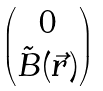Convert formula to latex. <formula><loc_0><loc_0><loc_500><loc_500>\begin{pmatrix} 0 \\ \tilde { B } ( \vec { r } ) \end{pmatrix}</formula> 